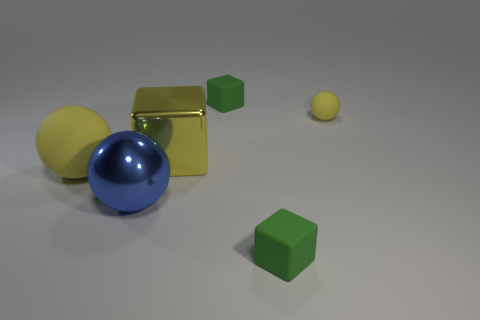Subtract all green matte blocks. How many blocks are left? 1 Subtract all blue balls. How many balls are left? 2 Subtract all blue blocks. Subtract all yellow balls. How many blocks are left? 3 Subtract all yellow spheres. How many red cubes are left? 0 Subtract all tiny cubes. Subtract all green rubber things. How many objects are left? 2 Add 4 large rubber objects. How many large rubber objects are left? 5 Add 3 tiny metallic cylinders. How many tiny metallic cylinders exist? 3 Add 3 small gray balls. How many objects exist? 9 Subtract 1 yellow balls. How many objects are left? 5 Subtract 1 cubes. How many cubes are left? 2 